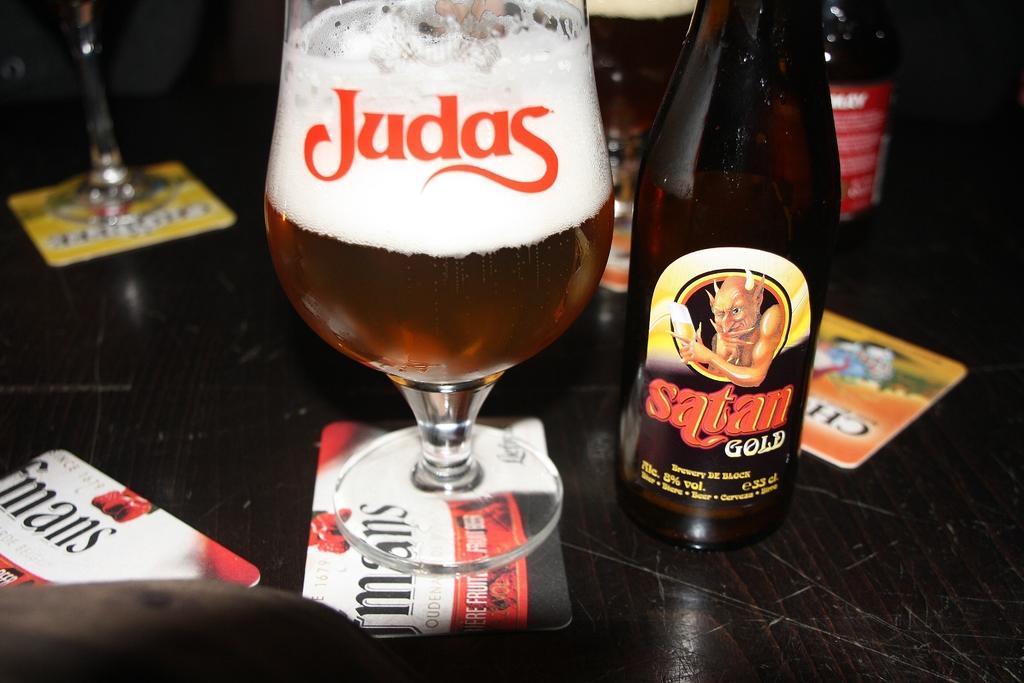Can you describe this image briefly? In the middle of the image, there is a glass filled with drink on the card which is on a table, on which there are bottles, cards and another glass on another card. And the background is dark in color. 